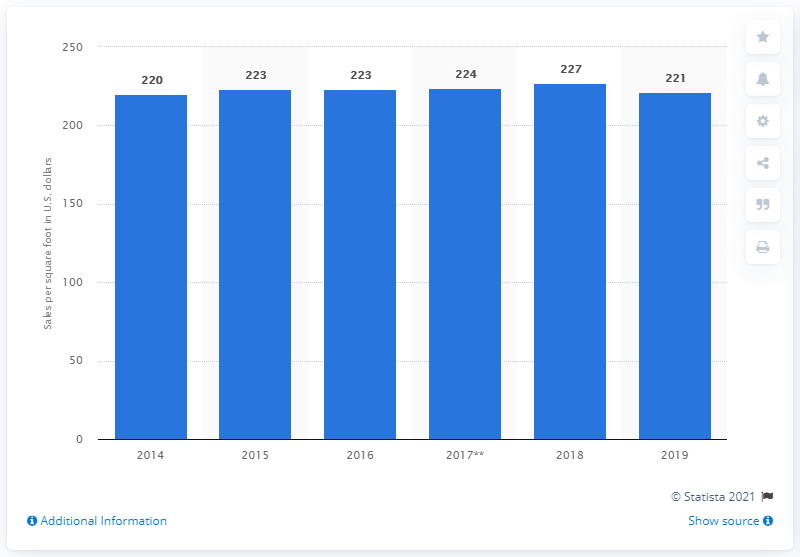Mention a couple of crucial points in this snapshot. In 2019, the average sales per square foot of Michaels stores was 221. 